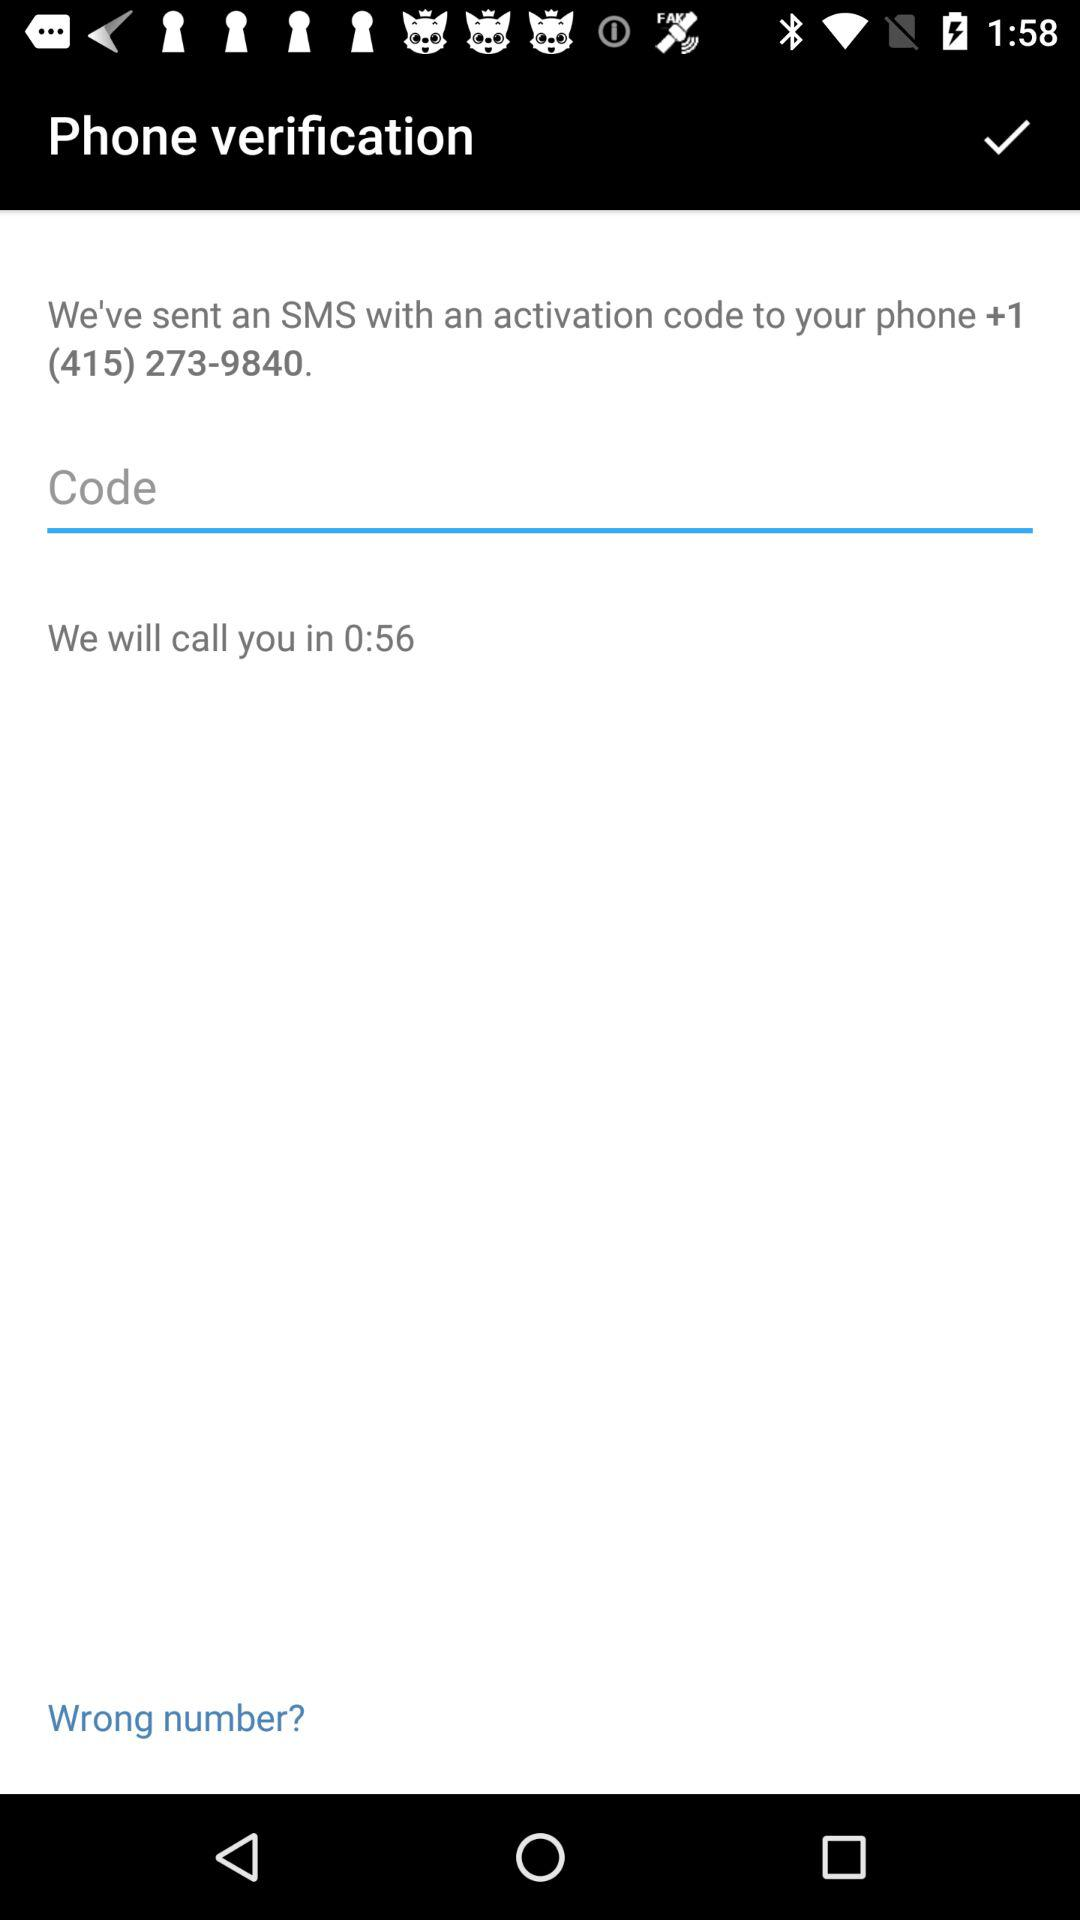How many minutes are left until the call?
Answer the question using a single word or phrase. 0:56 